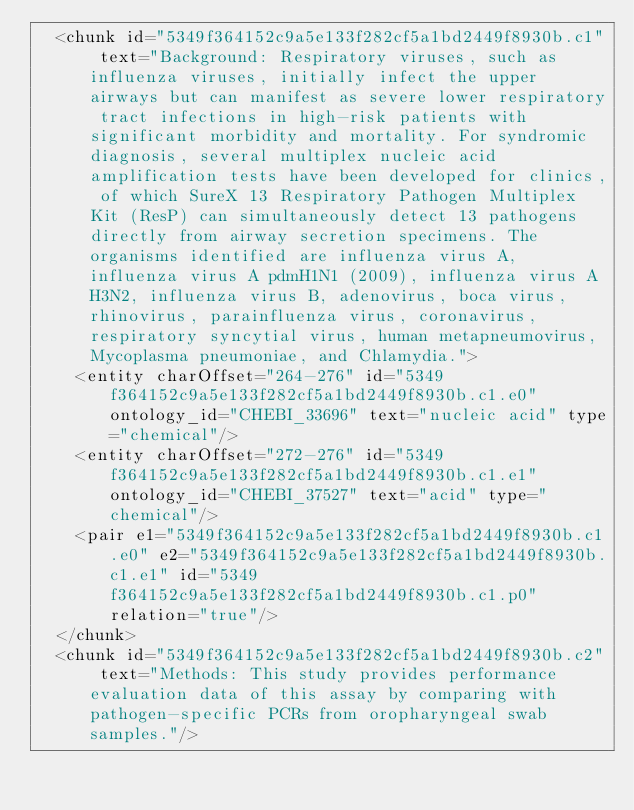Convert code to text. <code><loc_0><loc_0><loc_500><loc_500><_XML_>  <chunk id="5349f364152c9a5e133f282cf5a1bd2449f8930b.c1" text="Background: Respiratory viruses, such as influenza viruses, initially infect the upper airways but can manifest as severe lower respiratory tract infections in high-risk patients with significant morbidity and mortality. For syndromic diagnosis, several multiplex nucleic acid amplification tests have been developed for clinics, of which SureX 13 Respiratory Pathogen Multiplex Kit (ResP) can simultaneously detect 13 pathogens directly from airway secretion specimens. The organisms identified are influenza virus A, influenza virus A pdmH1N1 (2009), influenza virus A H3N2, influenza virus B, adenovirus, boca virus, rhinovirus, parainfluenza virus, coronavirus, respiratory syncytial virus, human metapneumovirus, Mycoplasma pneumoniae, and Chlamydia.">
    <entity charOffset="264-276" id="5349f364152c9a5e133f282cf5a1bd2449f8930b.c1.e0" ontology_id="CHEBI_33696" text="nucleic acid" type="chemical"/>
    <entity charOffset="272-276" id="5349f364152c9a5e133f282cf5a1bd2449f8930b.c1.e1" ontology_id="CHEBI_37527" text="acid" type="chemical"/>
    <pair e1="5349f364152c9a5e133f282cf5a1bd2449f8930b.c1.e0" e2="5349f364152c9a5e133f282cf5a1bd2449f8930b.c1.e1" id="5349f364152c9a5e133f282cf5a1bd2449f8930b.c1.p0" relation="true"/>
  </chunk>
  <chunk id="5349f364152c9a5e133f282cf5a1bd2449f8930b.c2" text="Methods: This study provides performance evaluation data of this assay by comparing with pathogen-specific PCRs from oropharyngeal swab samples."/></code> 